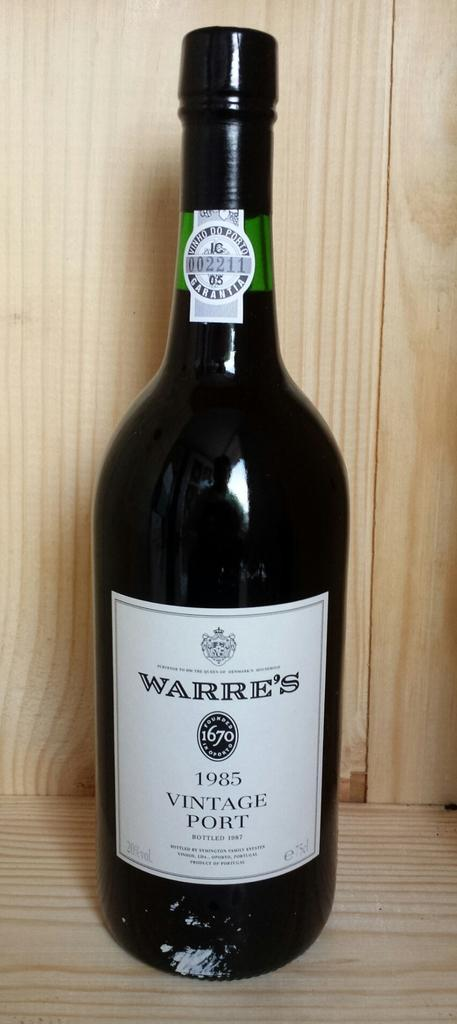<image>
Share a concise interpretation of the image provided. A bottle of Warre's 1985 Vintage Port is on a wooden shelf. 